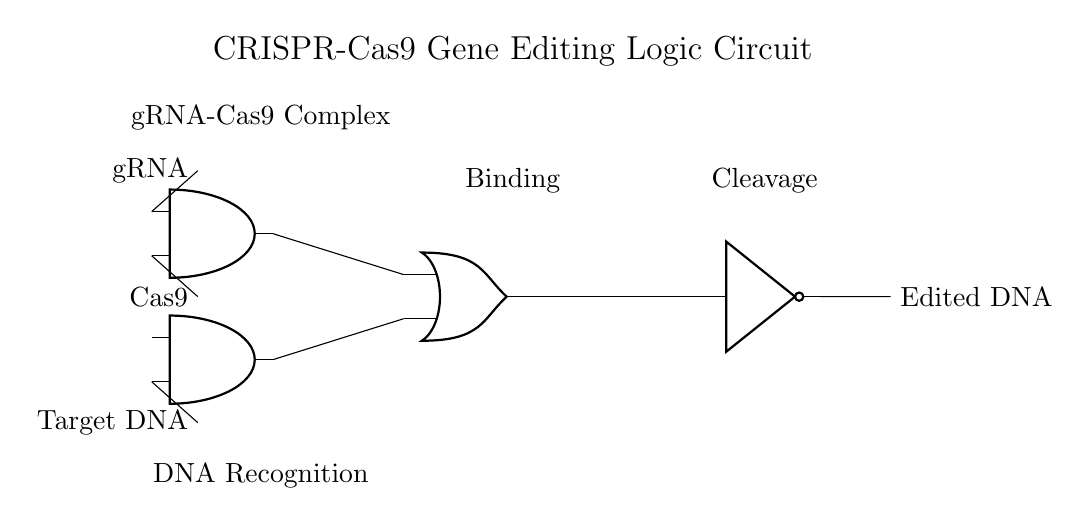what components are present in this circuit? The circuit contains an AND gate, an OR gate, a NOT gate, and three inputs: gRNA, Cas9, and Target DNA.
Answer: AND gate, OR gate, NOT gate, gRNA, Cas9, Target DNA what is the function of the AND gates in the circuit? The AND gates are used to combine the inputs; they output a signal only when all their inputs are active (gRNA and Cas9 for the first AND gate, and Target DNA for the second).
Answer: To combine inputs how many inputs does the OR gate have? The OR gate has two inputs, which come from the outputs of the two AND gates.
Answer: Two what is the final output of this circuit? The output of the circuit is Cleaved or Edited DNA, generated after processing inputs through the gates.
Answer: Edited DNA what is the role of the NOT gate in this logic circuit? The NOT gate inverts the signal received from the OR gate, providing the opposite output, which could be interpreted as preventing editing when certain conditions are not met.
Answer: Inversion of signal what condition must be met for the output to indicate Edited DNA? The conditions for the output to indicate Edited DNA involve both the AND gates producing a high output, which means that gRNA and Cas9 must be present and the Target DNA matched.
Answer: AND gate outputs high what do the labels "Binding" and "Cleavage" indicate in this context? "Binding" indicates the process where the gRNA-Cas9 complex attaches to the Target DNA, and "Cleavage" indicates the process of cutting the DNA, which is essential for gene editing.
Answer: Binding and Cleavage processes 